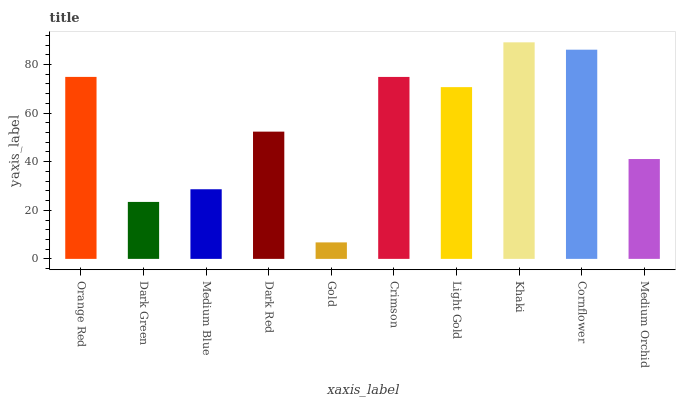Is Gold the minimum?
Answer yes or no. Yes. Is Khaki the maximum?
Answer yes or no. Yes. Is Dark Green the minimum?
Answer yes or no. No. Is Dark Green the maximum?
Answer yes or no. No. Is Orange Red greater than Dark Green?
Answer yes or no. Yes. Is Dark Green less than Orange Red?
Answer yes or no. Yes. Is Dark Green greater than Orange Red?
Answer yes or no. No. Is Orange Red less than Dark Green?
Answer yes or no. No. Is Light Gold the high median?
Answer yes or no. Yes. Is Dark Red the low median?
Answer yes or no. Yes. Is Gold the high median?
Answer yes or no. No. Is Gold the low median?
Answer yes or no. No. 